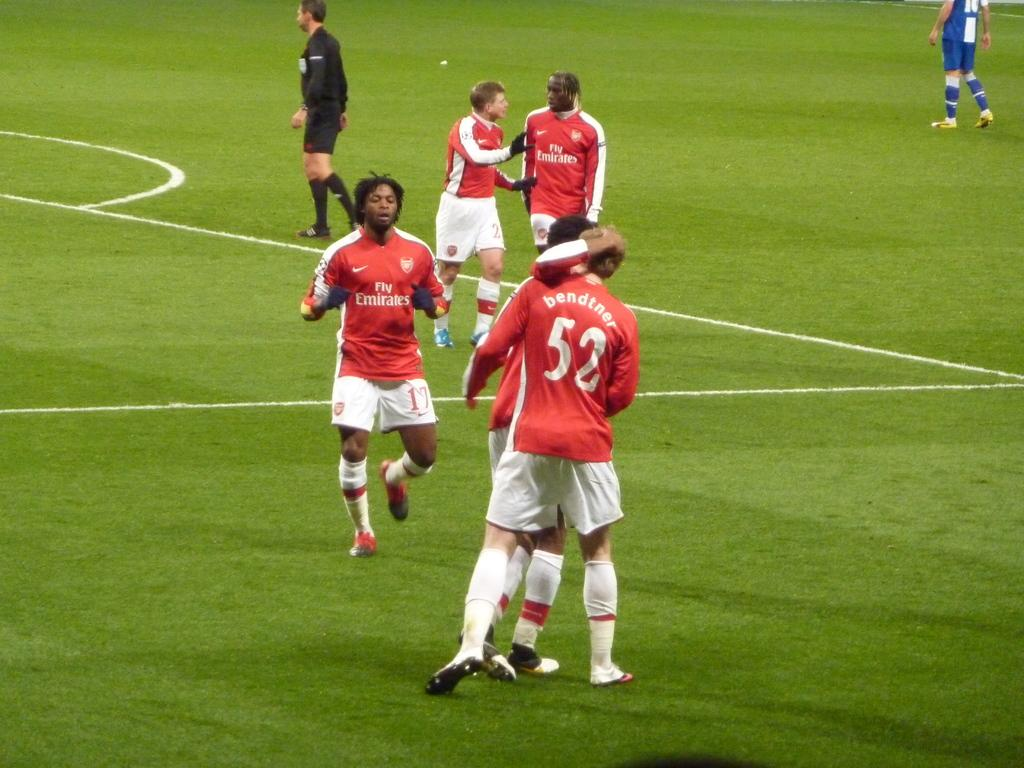<image>
Describe the image concisely. Player number 52 is being hugged by another player on the field. 